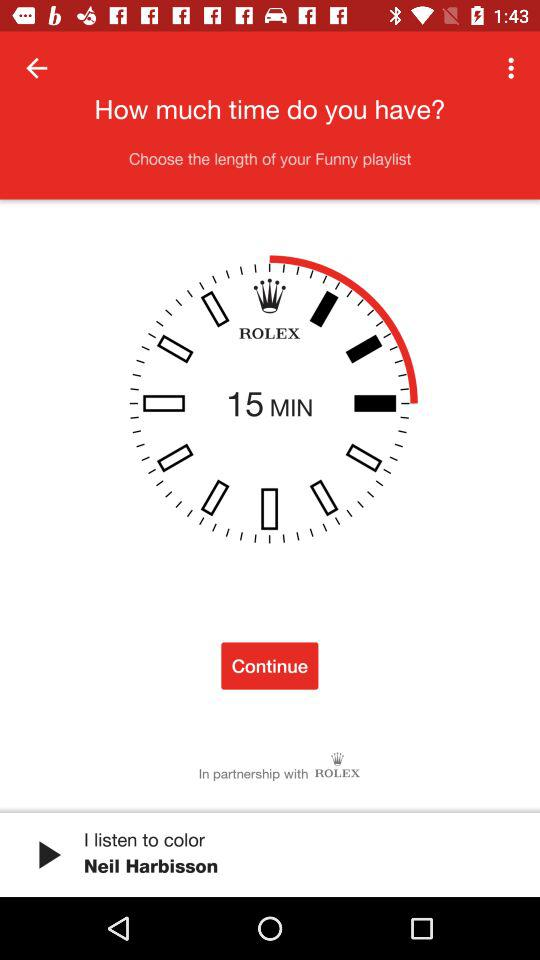How many minutes is the time shown on the clock? There are 15 minutes shown on the clock. 